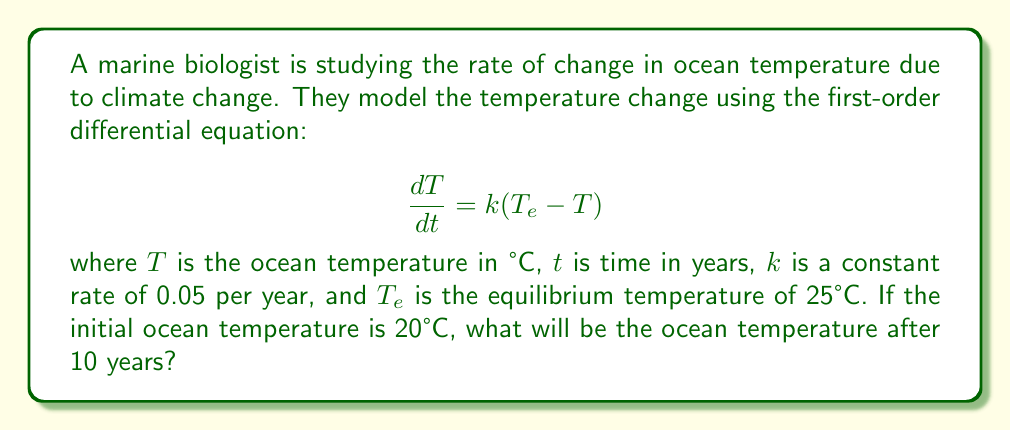Can you solve this math problem? To solve this problem, we need to use the solution to the first-order linear differential equation. The general solution for this type of equation is:

$$T(t) = T_e + (T_0 - T_e)e^{-kt}$$

Where:
- $T(t)$ is the temperature at time $t$
- $T_e$ is the equilibrium temperature (25°C)
- $T_0$ is the initial temperature (20°C)
- $k$ is the rate constant (0.05 per year)
- $t$ is the time (10 years)

Let's plug in these values:

$$T(10) = 25 + (20 - 25)e^{-0.05 \cdot 10}$$

Simplifying:
$$T(10) = 25 - 5e^{-0.5}$$

Using a calculator or computer to evaluate $e^{-0.5}$:
$$T(10) = 25 - 5 \cdot 0.6065$$
$$T(10) = 25 - 3.0325$$
$$T(10) = 21.9675$$

Rounding to two decimal places:
$$T(10) \approx 21.97°C$$
Answer: After 10 years, the ocean temperature will be approximately 21.97°C. 